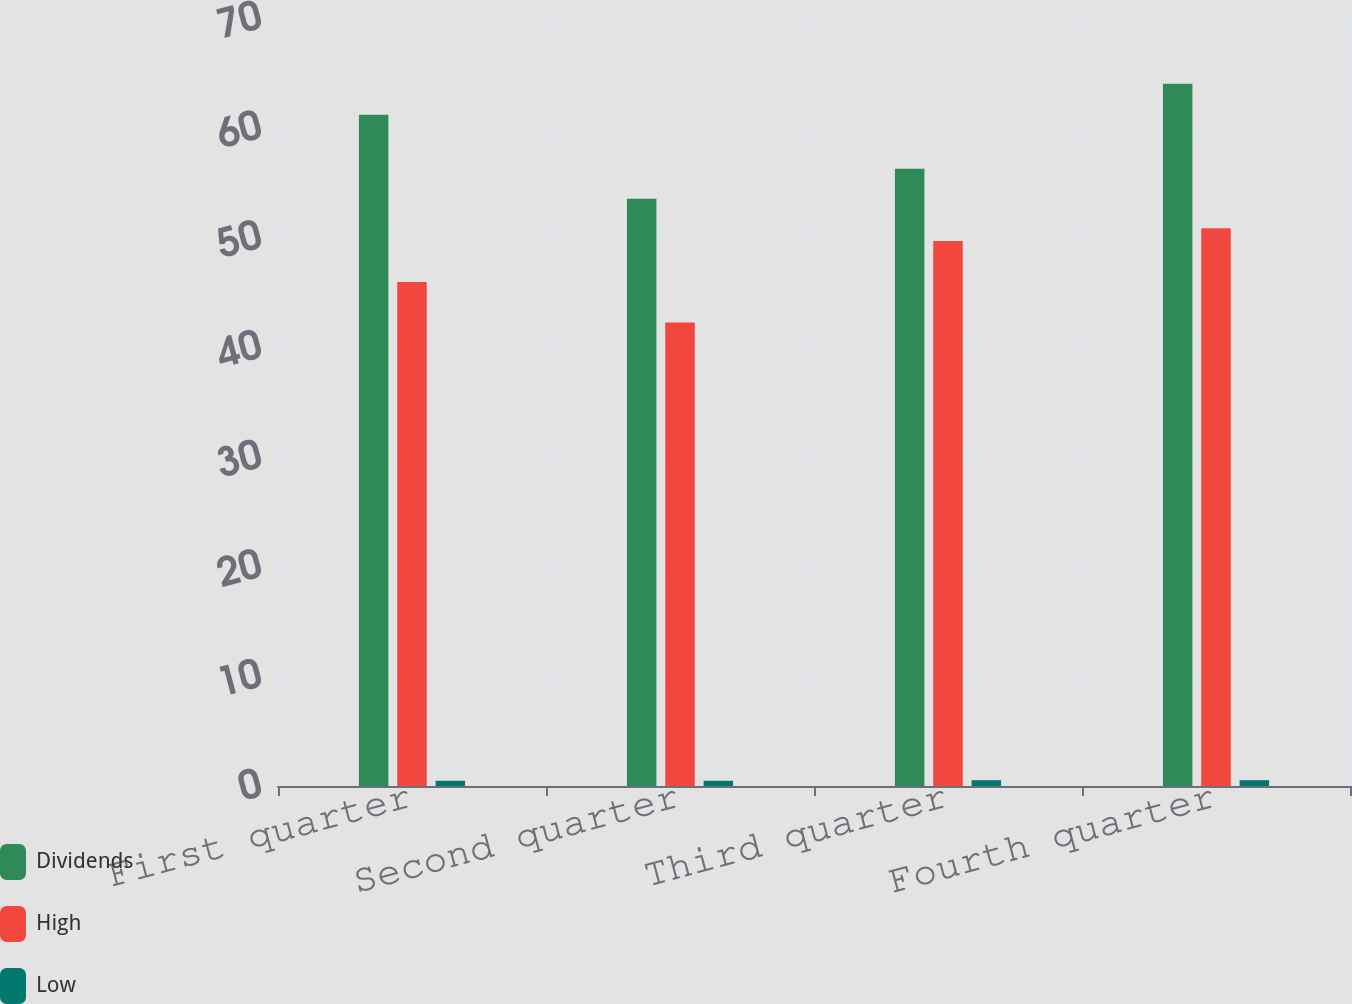<chart> <loc_0><loc_0><loc_500><loc_500><stacked_bar_chart><ecel><fcel>First quarter<fcel>Second quarter<fcel>Third quarter<fcel>Fourth quarter<nl><fcel>Dividends<fcel>61.19<fcel>53.52<fcel>56.27<fcel>64<nl><fcel>High<fcel>45.93<fcel>42.24<fcel>49.67<fcel>50.84<nl><fcel>Low<fcel>0.48<fcel>0.48<fcel>0.53<fcel>0.53<nl></chart> 